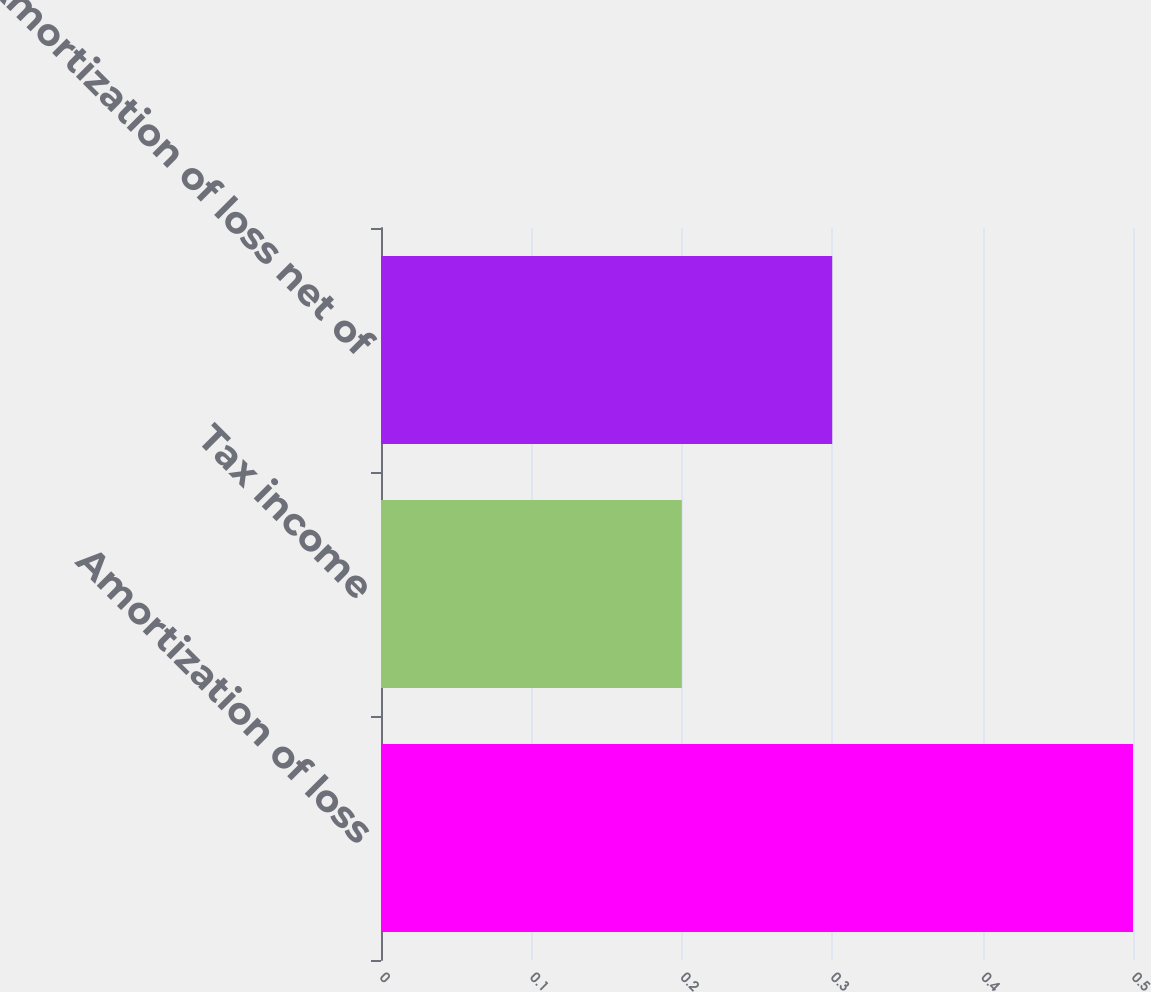Convert chart. <chart><loc_0><loc_0><loc_500><loc_500><bar_chart><fcel>Amortization of loss<fcel>Tax income<fcel>Amortization of loss net of<nl><fcel>0.5<fcel>0.2<fcel>0.3<nl></chart> 